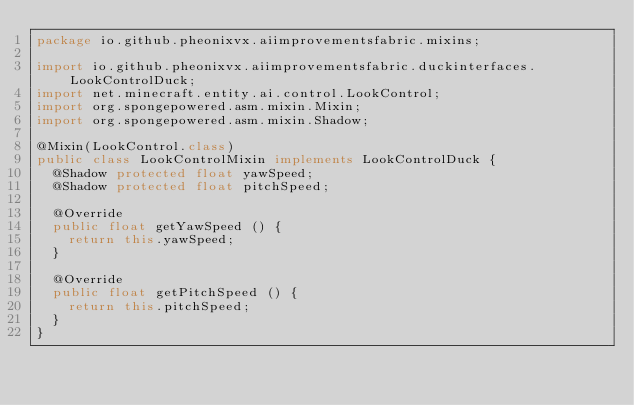<code> <loc_0><loc_0><loc_500><loc_500><_Java_>package io.github.pheonixvx.aiimprovementsfabric.mixins;

import io.github.pheonixvx.aiimprovementsfabric.duckinterfaces.LookControlDuck;
import net.minecraft.entity.ai.control.LookControl;
import org.spongepowered.asm.mixin.Mixin;
import org.spongepowered.asm.mixin.Shadow;

@Mixin(LookControl.class)
public class LookControlMixin implements LookControlDuck {
	@Shadow protected float yawSpeed;
	@Shadow protected float pitchSpeed;

	@Override
	public float getYawSpeed () {
		return this.yawSpeed;
	}

	@Override
	public float getPitchSpeed () {
		return this.pitchSpeed;
	}
}
</code> 